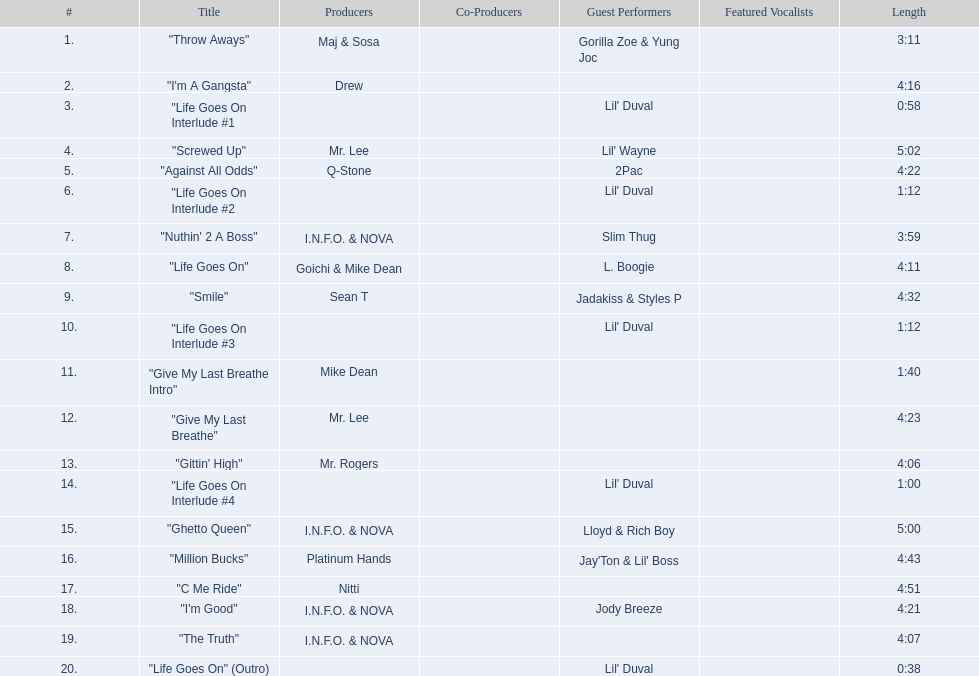What are the song lengths of all the songs on the album? 3:11, 4:16, 0:58, 5:02, 4:22, 1:12, 3:59, 4:11, 4:32, 1:12, 1:40, 4:23, 4:06, 1:00, 5:00, 4:43, 4:51, 4:21, 4:07, 0:38. Which is the longest of these? 5:02. 